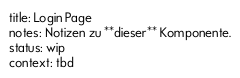Convert code to text. <code><loc_0><loc_0><loc_500><loc_500><_YAML_>title: Login Page
notes: Notizen zu **dieser** Komponente.
status: wip
context: tbd
</code> 